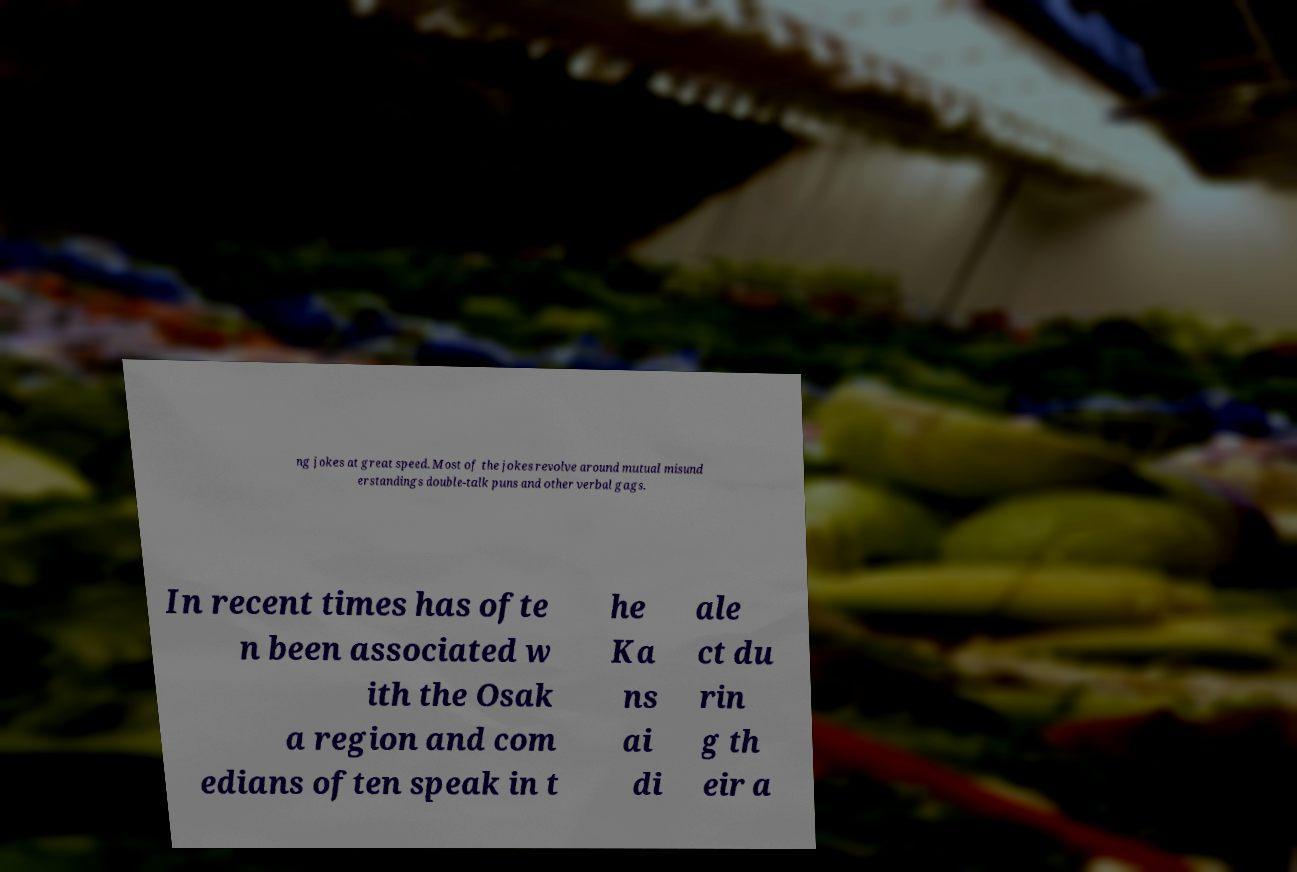What messages or text are displayed in this image? I need them in a readable, typed format. ng jokes at great speed. Most of the jokes revolve around mutual misund erstandings double-talk puns and other verbal gags. In recent times has ofte n been associated w ith the Osak a region and com edians often speak in t he Ka ns ai di ale ct du rin g th eir a 